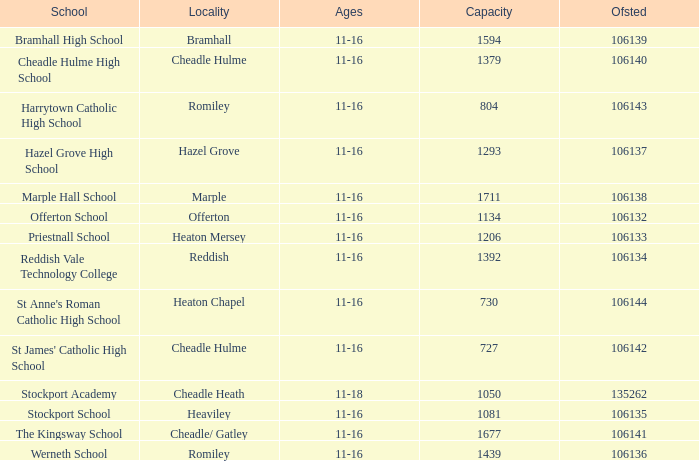Which School has Ages of 11-16, and an Ofsted smaller than 106142, and a Capacity of 1206? Priestnall School. 